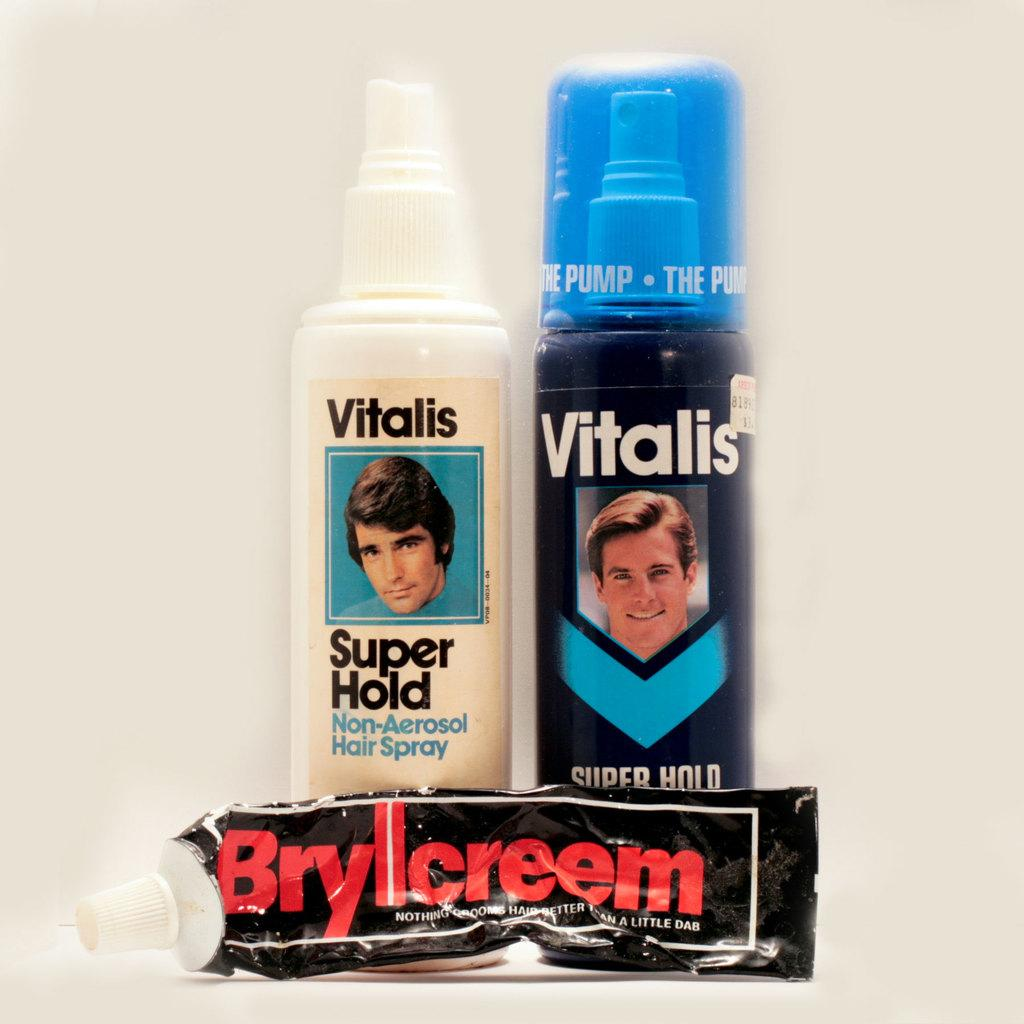<image>
Offer a succinct explanation of the picture presented. A trio of men's hair products Vitalis Super Hold and Brylcreem is shown. 